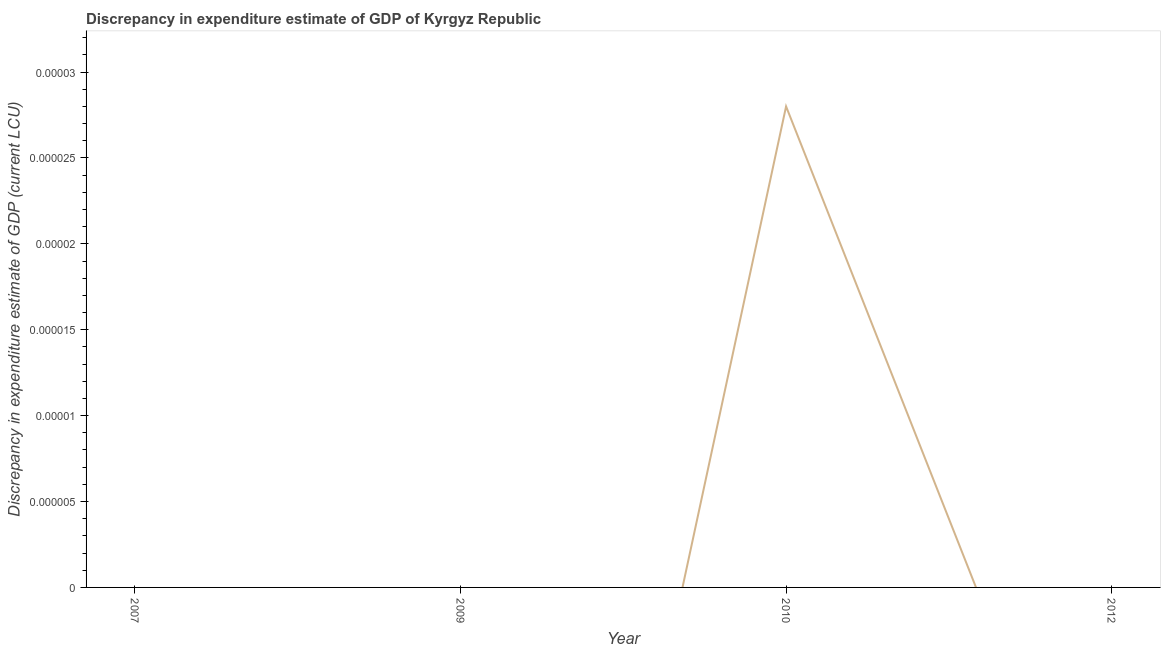Across all years, what is the maximum discrepancy in expenditure estimate of gdp?
Your answer should be very brief. 2.800000000000001e-5. Across all years, what is the minimum discrepancy in expenditure estimate of gdp?
Your response must be concise. 0. In which year was the discrepancy in expenditure estimate of gdp maximum?
Provide a short and direct response. 2010. What is the sum of the discrepancy in expenditure estimate of gdp?
Make the answer very short. 2.800000000000001e-5. What is the average discrepancy in expenditure estimate of gdp per year?
Your answer should be compact. 7.0000000000000024e-6. What is the median discrepancy in expenditure estimate of gdp?
Your answer should be compact. 0. In how many years, is the discrepancy in expenditure estimate of gdp greater than 2.2e-05 LCU?
Ensure brevity in your answer.  1. What is the difference between the highest and the lowest discrepancy in expenditure estimate of gdp?
Your answer should be compact. 2.800000000000001e-5. How many lines are there?
Make the answer very short. 1. What is the difference between two consecutive major ticks on the Y-axis?
Your answer should be compact. 5e-6. What is the title of the graph?
Provide a succinct answer. Discrepancy in expenditure estimate of GDP of Kyrgyz Republic. What is the label or title of the X-axis?
Keep it short and to the point. Year. What is the label or title of the Y-axis?
Offer a very short reply. Discrepancy in expenditure estimate of GDP (current LCU). What is the Discrepancy in expenditure estimate of GDP (current LCU) in 2009?
Provide a short and direct response. 0. What is the Discrepancy in expenditure estimate of GDP (current LCU) in 2010?
Give a very brief answer. 2.800000000000001e-5. 